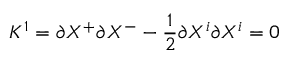<formula> <loc_0><loc_0><loc_500><loc_500>K ^ { 1 } = \partial X ^ { + } \partial X ^ { - } - \frac { 1 } { 2 } \partial X ^ { i } \partial X ^ { i } = 0</formula> 